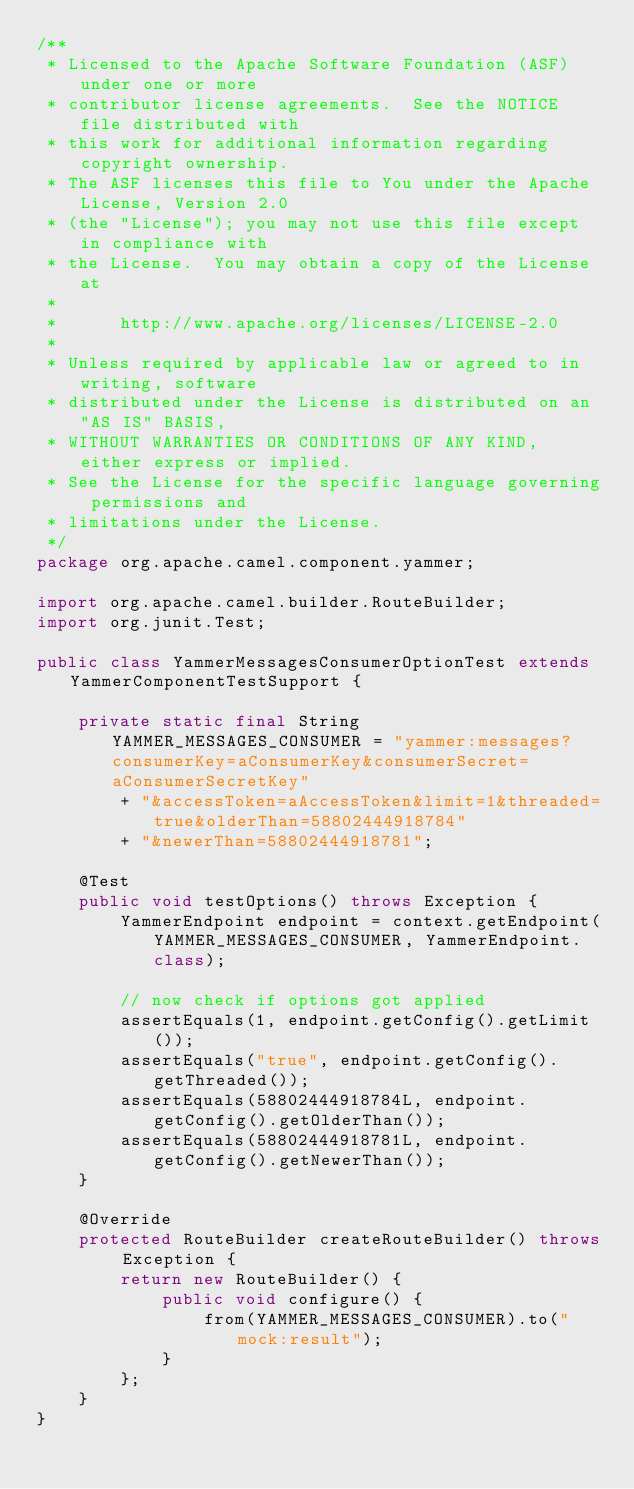Convert code to text. <code><loc_0><loc_0><loc_500><loc_500><_Java_>/**
 * Licensed to the Apache Software Foundation (ASF) under one or more
 * contributor license agreements.  See the NOTICE file distributed with
 * this work for additional information regarding copyright ownership.
 * The ASF licenses this file to You under the Apache License, Version 2.0
 * (the "License"); you may not use this file except in compliance with
 * the License.  You may obtain a copy of the License at
 *
 *      http://www.apache.org/licenses/LICENSE-2.0
 *
 * Unless required by applicable law or agreed to in writing, software
 * distributed under the License is distributed on an "AS IS" BASIS,
 * WITHOUT WARRANTIES OR CONDITIONS OF ANY KIND, either express or implied.
 * See the License for the specific language governing permissions and
 * limitations under the License.
 */
package org.apache.camel.component.yammer;

import org.apache.camel.builder.RouteBuilder;
import org.junit.Test;

public class YammerMessagesConsumerOptionTest extends YammerComponentTestSupport {

    private static final String YAMMER_MESSAGES_CONSUMER = "yammer:messages?consumerKey=aConsumerKey&consumerSecret=aConsumerSecretKey" 
        + "&accessToken=aAccessToken&limit=1&threaded=true&olderThan=58802444918784"
        + "&newerThan=58802444918781";

    @Test
    public void testOptions() throws Exception {
        YammerEndpoint endpoint = context.getEndpoint(YAMMER_MESSAGES_CONSUMER, YammerEndpoint.class);
        
        // now check if options got applied
        assertEquals(1, endpoint.getConfig().getLimit());
        assertEquals("true", endpoint.getConfig().getThreaded());
        assertEquals(58802444918784L, endpoint.getConfig().getOlderThan());
        assertEquals(58802444918781L, endpoint.getConfig().getNewerThan());
    }

    @Override
    protected RouteBuilder createRouteBuilder() throws Exception {
        return new RouteBuilder() {
            public void configure() {
                from(YAMMER_MESSAGES_CONSUMER).to("mock:result");
            }
        };
    }
}
</code> 